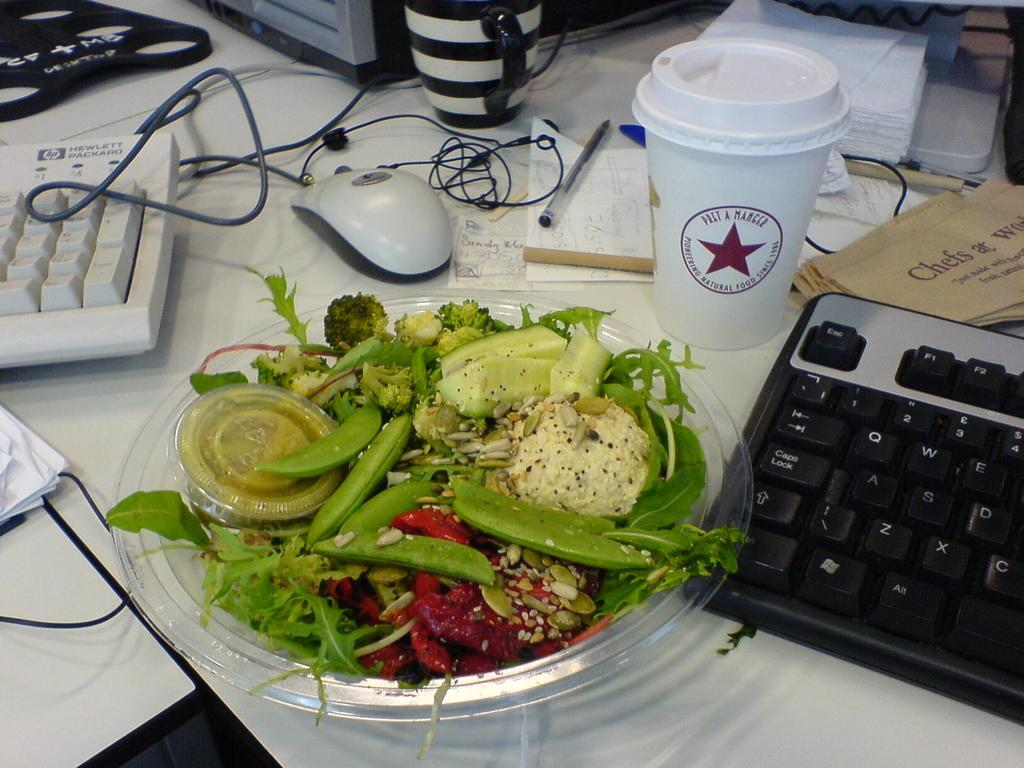What is the main piece of furniture in the image? There is a table in the image. What electronic devices can be seen on the table? There are two keyboards and a mouse on the table. What type of beverage container is on the table? There is a glass on the table. What type of wires are present on the table? There are wires on the table. What type of writing instrument is on the table? There is a pen on the table. What type of reading material is on the table? There are books on the table. What type of drinking container is on the table? There is a cup on the table. What type of paper items are on the table? There are papers on the table. What type of food items are on the table? There is a plate with food items on the table. What other objects are on the table? There are other objects on the table. What type of alarm is ringing in the image? There is no alarm present in the image. What type of hand is visible in the image? There are no hands visible in the image. 